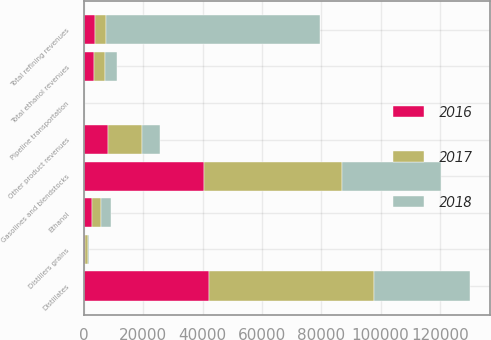Convert chart. <chart><loc_0><loc_0><loc_500><loc_500><stacked_bar_chart><ecel><fcel>Gasolines and blendstocks<fcel>Distillates<fcel>Other product revenues<fcel>Total refining revenues<fcel>Ethanol<fcel>Distillers grains<fcel>Total ethanol revenues<fcel>Pipeline transportation<nl><fcel>2017<fcel>46606<fcel>55546<fcel>11463<fcel>3769.5<fcel>2912<fcel>726<fcel>3638<fcel>124<nl><fcel>2016<fcel>40366<fcel>42074<fcel>8217<fcel>3769.5<fcel>2940<fcel>560<fcel>3500<fcel>101<nl><fcel>2018<fcel>33450<fcel>32576<fcel>5942<fcel>71968<fcel>3315<fcel>586<fcel>3901<fcel>78<nl></chart> 